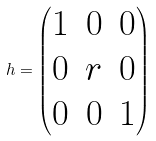<formula> <loc_0><loc_0><loc_500><loc_500>h = \begin{pmatrix} 1 & 0 & 0 \\ 0 & r & 0 \\ 0 & 0 & 1 \end{pmatrix}</formula> 